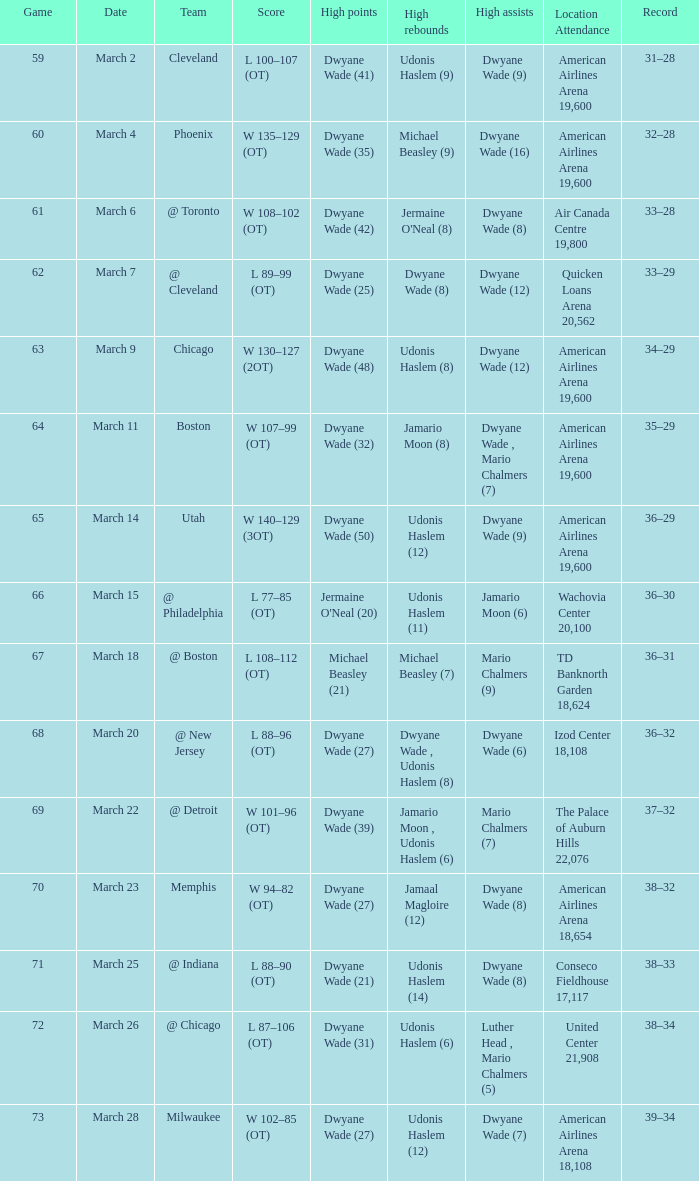What team(s) did they play on march 9? Chicago. 